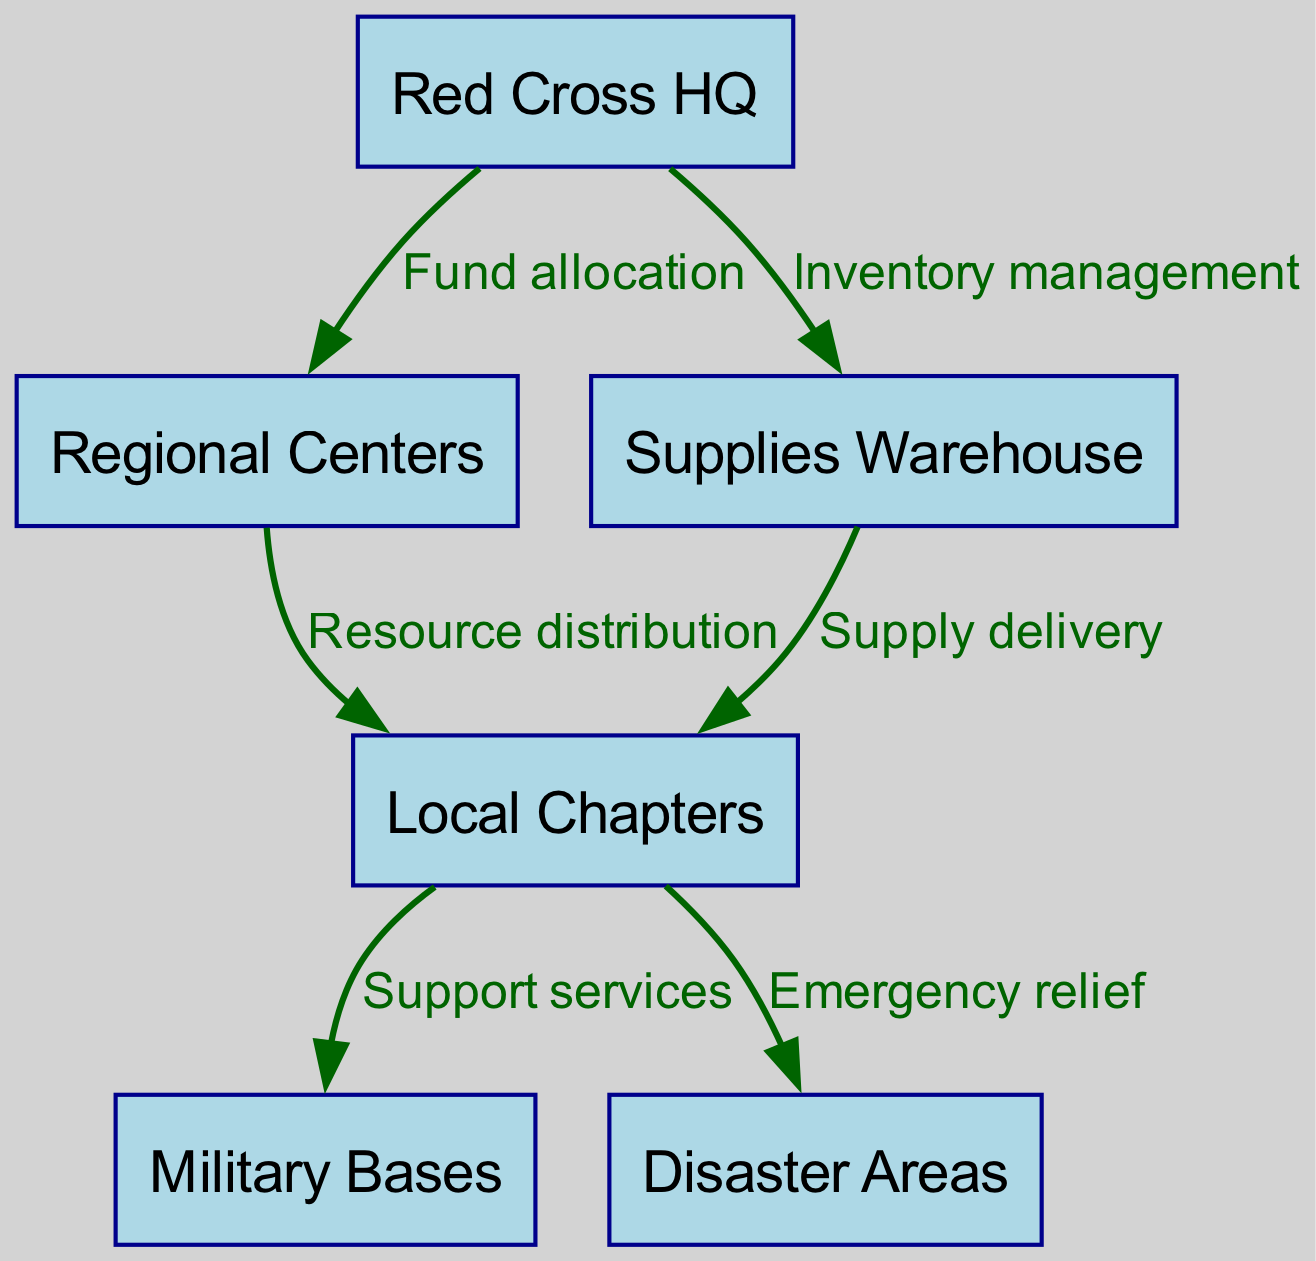What is the top-level node in the diagram? The top-level node in the diagram is "Red Cross HQ," which represents the organization at the highest level overseeing all other operations.
Answer: Red Cross HQ How many nodes are present in the diagram? The diagram contains six nodes: Red Cross HQ, Regional Centers, Local Chapters, Military Bases, Disaster Areas, and Supplies Warehouse.
Answer: 6 What is the flow of resource distribution from Red Cross HQ to Local Chapters? Resources flow from the Red Cross HQ to Regional Centers through a "Fund allocation" edge, and subsequently from Regional Centers to Local Chapters under "Resource distribution."
Answer: Fund allocation, Resource distribution Which node receives support services directly from Local Chapters? Local Chapters provide support services directly to the Military Bases, conveying a critical connection between community efforts and military support.
Answer: Military Bases What type of operation is connected to the edge between Local Chapters and Disaster Areas? The edge connecting Local Chapters and Disaster Areas depicts "Emergency relief," indicating that this route is used for delivering aid directly where it's most needed.
Answer: Emergency relief How are supplies delivered to Local Chapters? Supplies are delivered to Local Chapters from the Supplies Warehouse, which indicates a logistical operation focused on ensuring that local response teams have necessary resources.
Answer: Supply delivery Which two nodes are directly connected to Red Cross HQ? Red Cross HQ is directly connected to the Regional Centers and the Supplies Warehouse, highlighting its logistical and financial oversight roles.
Answer: Regional Centers, Supplies Warehouse How does Inventory management relate to supplies in the diagram? Inventory management at the Red Cross HQ directly affects the supplies held in the Supplies Warehouse, illustrating the importance of managerial oversight in resource availability.
Answer: Supplies Warehouse What is the total number of edges in the diagram? The diagram illustrates five edges: one for each type of connection or relationship established between nodes within the resource allocation system.
Answer: 6 